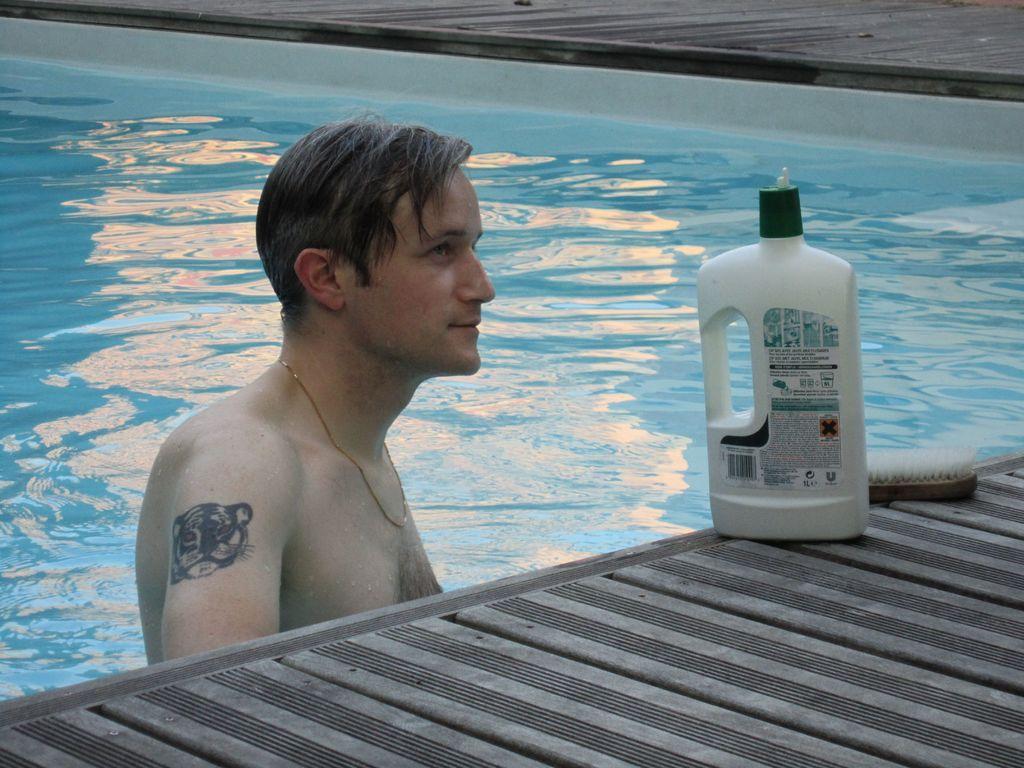Describe this image in one or two sentences. In this image there is a man in the swimming pool. On the right there is a bottle and a brush placed on the floor. 